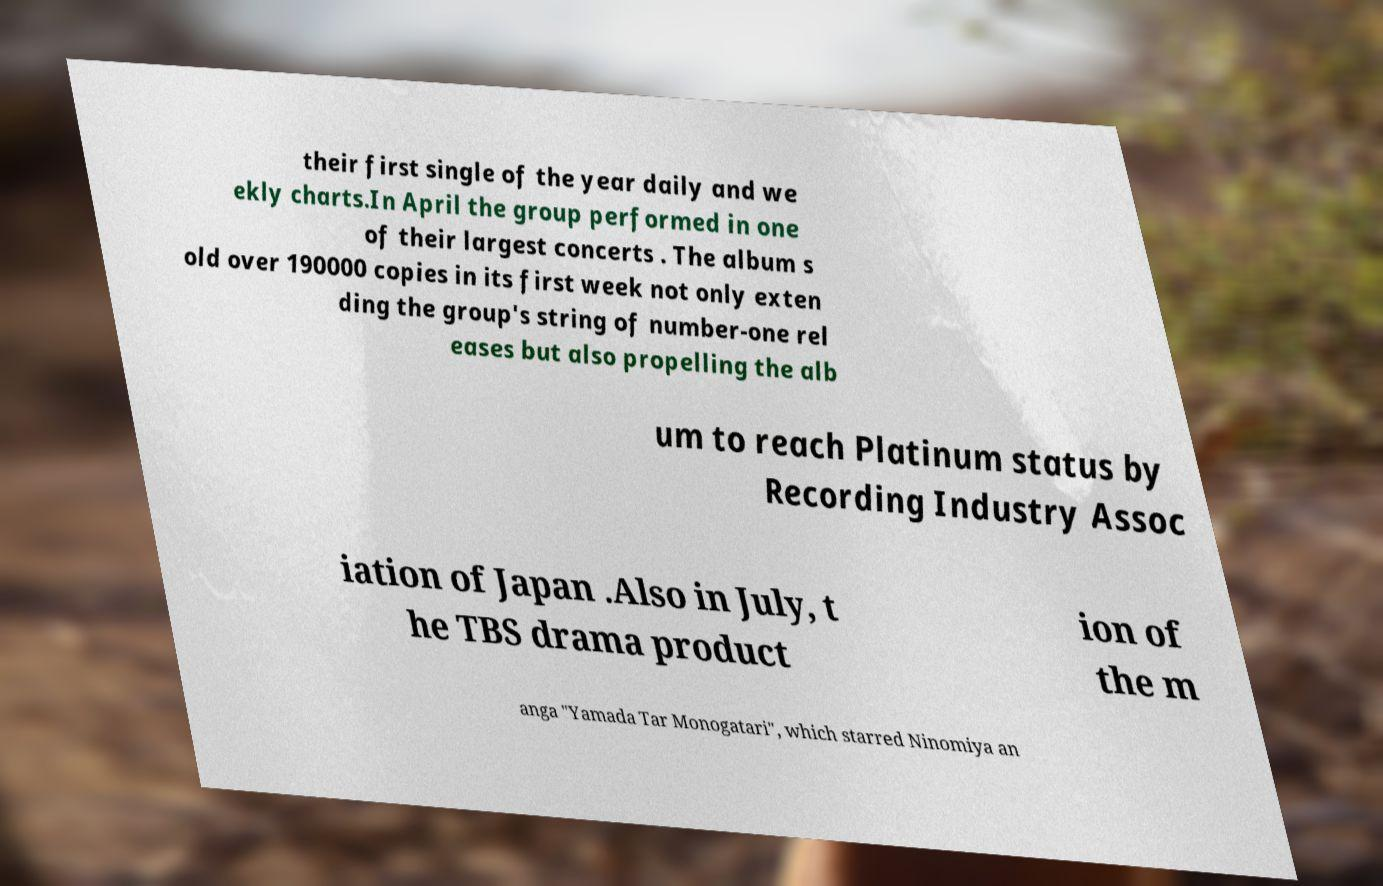Please identify and transcribe the text found in this image. their first single of the year daily and we ekly charts.In April the group performed in one of their largest concerts . The album s old over 190000 copies in its first week not only exten ding the group's string of number-one rel eases but also propelling the alb um to reach Platinum status by Recording Industry Assoc iation of Japan .Also in July, t he TBS drama product ion of the m anga "Yamada Tar Monogatari", which starred Ninomiya an 